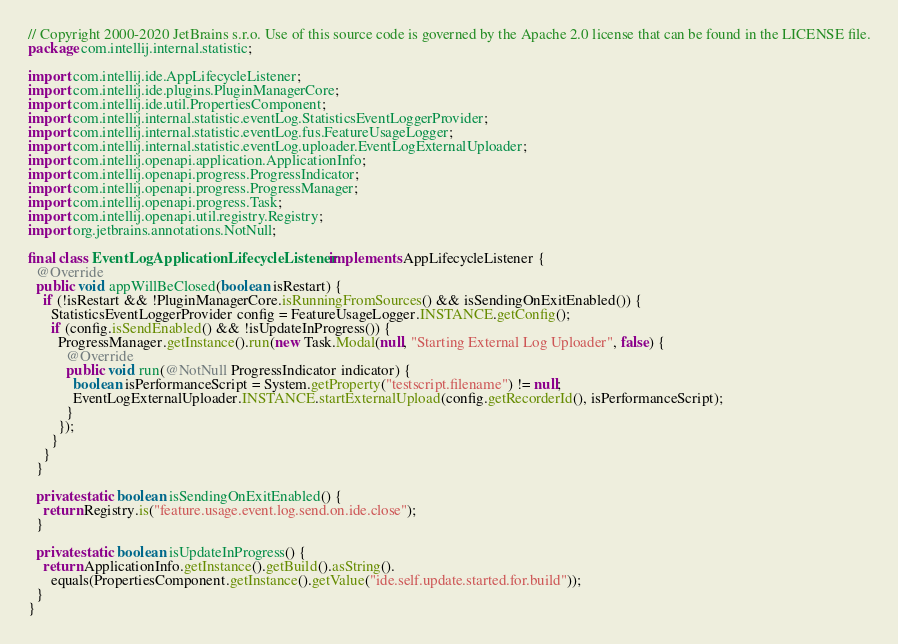<code> <loc_0><loc_0><loc_500><loc_500><_Java_>// Copyright 2000-2020 JetBrains s.r.o. Use of this source code is governed by the Apache 2.0 license that can be found in the LICENSE file.
package com.intellij.internal.statistic;

import com.intellij.ide.AppLifecycleListener;
import com.intellij.ide.plugins.PluginManagerCore;
import com.intellij.ide.util.PropertiesComponent;
import com.intellij.internal.statistic.eventLog.StatisticsEventLoggerProvider;
import com.intellij.internal.statistic.eventLog.fus.FeatureUsageLogger;
import com.intellij.internal.statistic.eventLog.uploader.EventLogExternalUploader;
import com.intellij.openapi.application.ApplicationInfo;
import com.intellij.openapi.progress.ProgressIndicator;
import com.intellij.openapi.progress.ProgressManager;
import com.intellij.openapi.progress.Task;
import com.intellij.openapi.util.registry.Registry;
import org.jetbrains.annotations.NotNull;

final class EventLogApplicationLifecycleListener implements AppLifecycleListener {
  @Override
  public void appWillBeClosed(boolean isRestart) {
    if (!isRestart && !PluginManagerCore.isRunningFromSources() && isSendingOnExitEnabled()) {
      StatisticsEventLoggerProvider config = FeatureUsageLogger.INSTANCE.getConfig();
      if (config.isSendEnabled() && !isUpdateInProgress()) {
        ProgressManager.getInstance().run(new Task.Modal(null, "Starting External Log Uploader", false) {
          @Override
          public void run(@NotNull ProgressIndicator indicator) {
            boolean isPerformanceScript = System.getProperty("testscript.filename") != null;
            EventLogExternalUploader.INSTANCE.startExternalUpload(config.getRecorderId(), isPerformanceScript);
          }
        });
      }
    }
  }

  private static boolean isSendingOnExitEnabled() {
    return Registry.is("feature.usage.event.log.send.on.ide.close");
  }

  private static boolean isUpdateInProgress() {
    return ApplicationInfo.getInstance().getBuild().asString().
      equals(PropertiesComponent.getInstance().getValue("ide.self.update.started.for.build"));
  }
}
</code> 